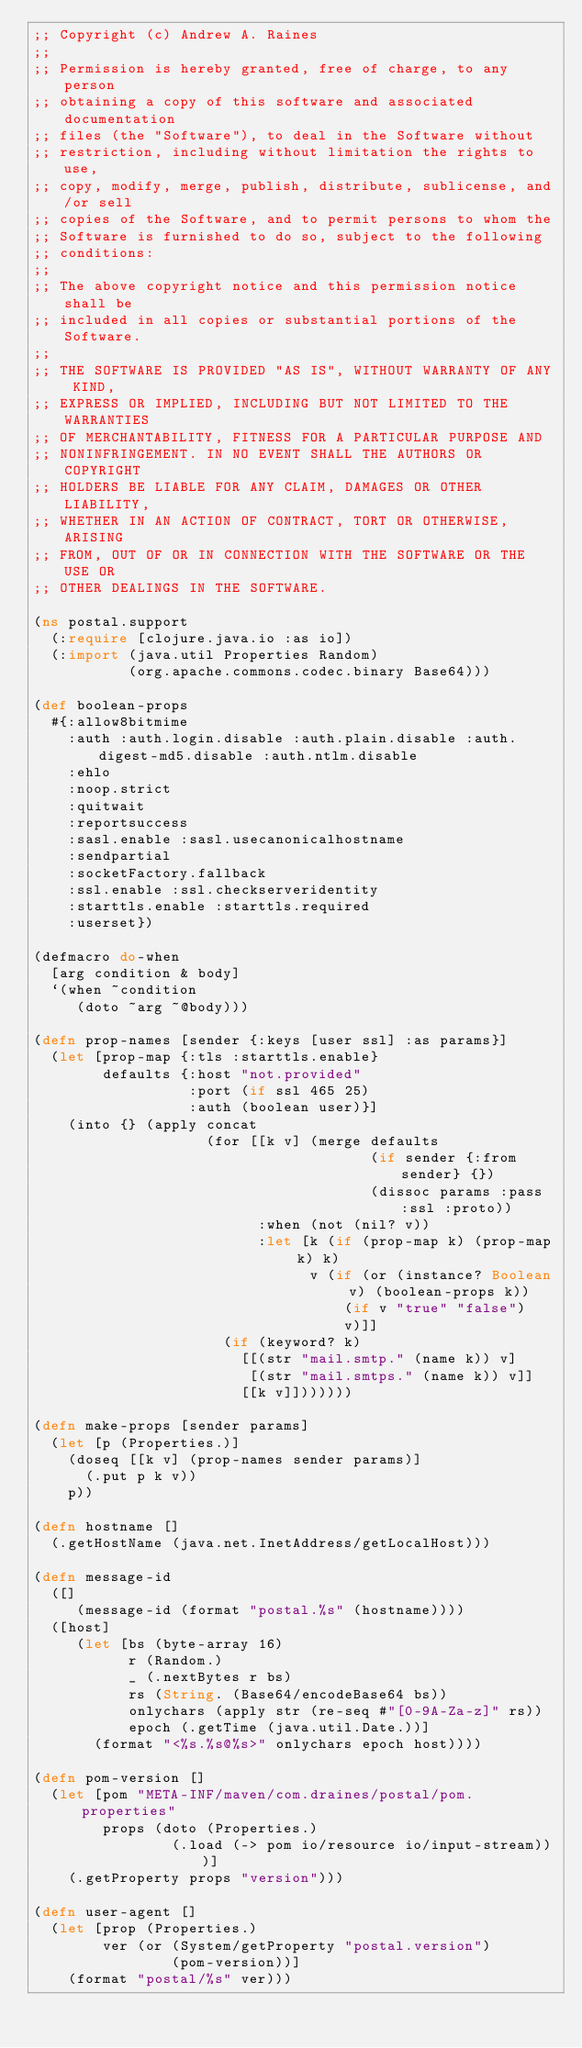<code> <loc_0><loc_0><loc_500><loc_500><_Clojure_>;; Copyright (c) Andrew A. Raines
;;
;; Permission is hereby granted, free of charge, to any person
;; obtaining a copy of this software and associated documentation
;; files (the "Software"), to deal in the Software without
;; restriction, including without limitation the rights to use,
;; copy, modify, merge, publish, distribute, sublicense, and/or sell
;; copies of the Software, and to permit persons to whom the
;; Software is furnished to do so, subject to the following
;; conditions:
;;
;; The above copyright notice and this permission notice shall be
;; included in all copies or substantial portions of the Software.
;;
;; THE SOFTWARE IS PROVIDED "AS IS", WITHOUT WARRANTY OF ANY KIND,
;; EXPRESS OR IMPLIED, INCLUDING BUT NOT LIMITED TO THE WARRANTIES
;; OF MERCHANTABILITY, FITNESS FOR A PARTICULAR PURPOSE AND
;; NONINFRINGEMENT. IN NO EVENT SHALL THE AUTHORS OR COPYRIGHT
;; HOLDERS BE LIABLE FOR ANY CLAIM, DAMAGES OR OTHER LIABILITY,
;; WHETHER IN AN ACTION OF CONTRACT, TORT OR OTHERWISE, ARISING
;; FROM, OUT OF OR IN CONNECTION WITH THE SOFTWARE OR THE USE OR
;; OTHER DEALINGS IN THE SOFTWARE.

(ns postal.support
  (:require [clojure.java.io :as io])
  (:import (java.util Properties Random)
           (org.apache.commons.codec.binary Base64)))

(def boolean-props
  #{:allow8bitmime
    :auth :auth.login.disable :auth.plain.disable :auth.digest-md5.disable :auth.ntlm.disable
    :ehlo
    :noop.strict
    :quitwait
    :reportsuccess
    :sasl.enable :sasl.usecanonicalhostname
    :sendpartial
    :socketFactory.fallback
    :ssl.enable :ssl.checkserveridentity
    :starttls.enable :starttls.required
    :userset})

(defmacro do-when
  [arg condition & body]
  `(when ~condition
     (doto ~arg ~@body)))

(defn prop-names [sender {:keys [user ssl] :as params}]
  (let [prop-map {:tls :starttls.enable}
        defaults {:host "not.provided"
                  :port (if ssl 465 25)
                  :auth (boolean user)}]
    (into {} (apply concat
                    (for [[k v] (merge defaults
                                       (if sender {:from sender} {})
                                       (dissoc params :pass :ssl :proto))
                          :when (not (nil? v))
                          :let [k (if (prop-map k) (prop-map k) k)
                                v (if (or (instance? Boolean v) (boolean-props k))
                                    (if v "true" "false")
                                    v)]]
                      (if (keyword? k)
                        [[(str "mail.smtp." (name k)) v]
                         [(str "mail.smtps." (name k)) v]]
                        [[k v]]))))))

(defn make-props [sender params]
  (let [p (Properties.)]
    (doseq [[k v] (prop-names sender params)]
      (.put p k v))
    p))

(defn hostname []
  (.getHostName (java.net.InetAddress/getLocalHost)))

(defn message-id
  ([]
     (message-id (format "postal.%s" (hostname))))
  ([host]
     (let [bs (byte-array 16)
           r (Random.)
           _ (.nextBytes r bs)
           rs (String. (Base64/encodeBase64 bs))
           onlychars (apply str (re-seq #"[0-9A-Za-z]" rs))
           epoch (.getTime (java.util.Date.))]
       (format "<%s.%s@%s>" onlychars epoch host))))

(defn pom-version []
  (let [pom "META-INF/maven/com.draines/postal/pom.properties"
        props (doto (Properties.)
                (.load (-> pom io/resource io/input-stream)))]
    (.getProperty props "version")))

(defn user-agent []
  (let [prop (Properties.)
        ver (or (System/getProperty "postal.version")
                (pom-version))]
    (format "postal/%s" ver)))
</code> 